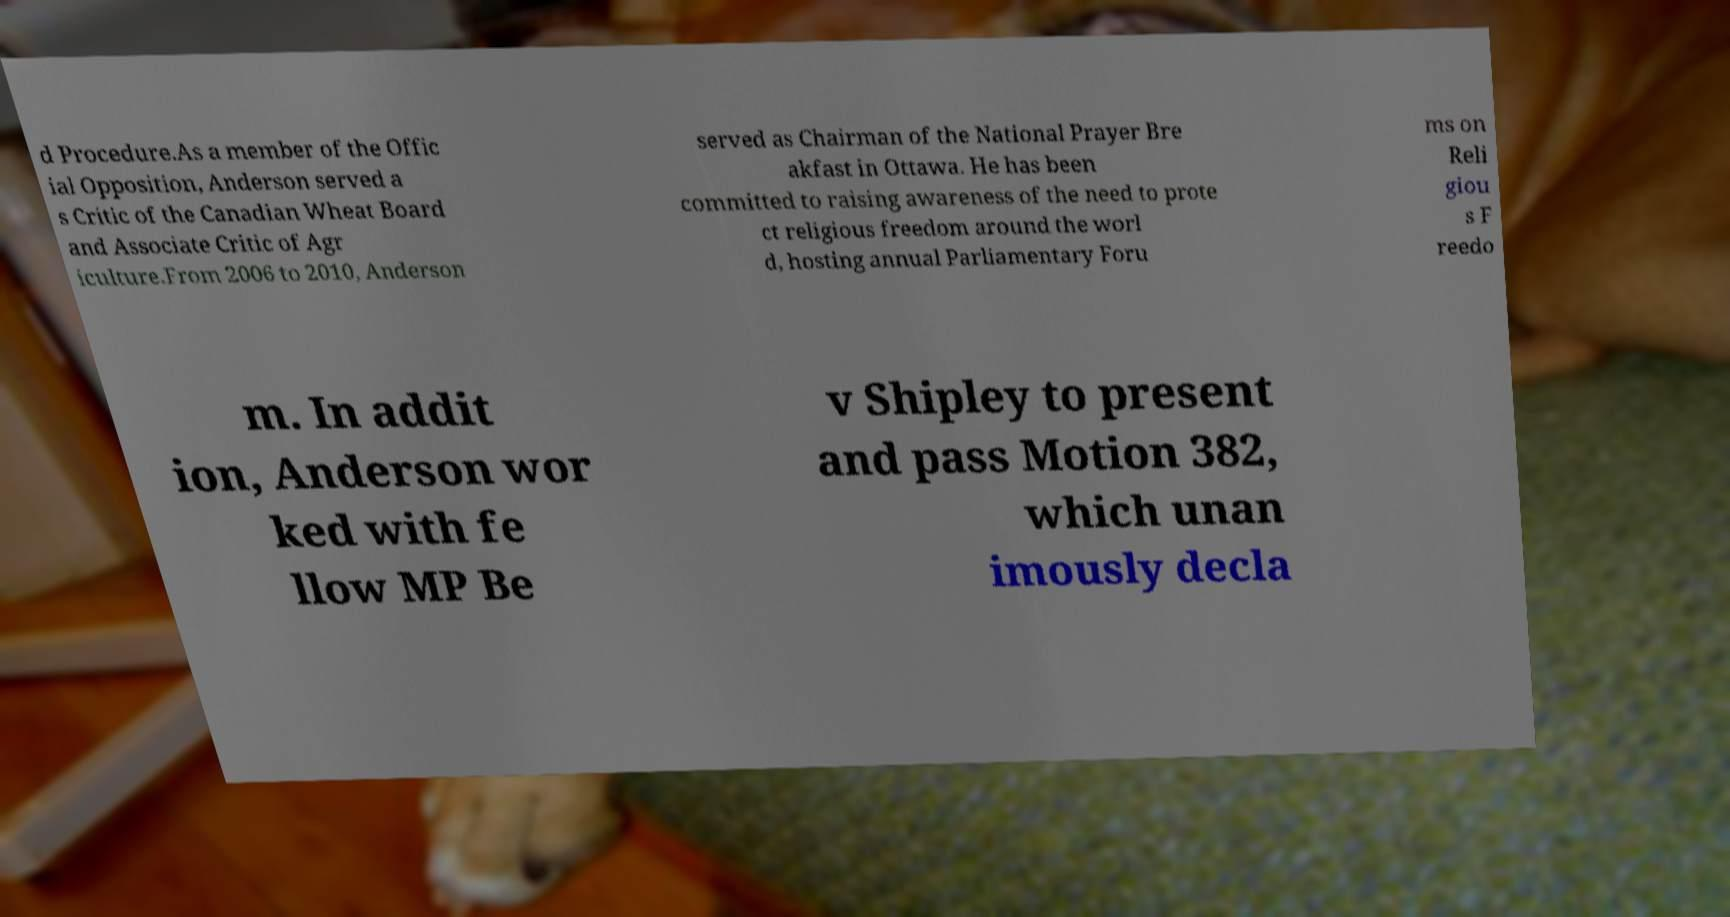For documentation purposes, I need the text within this image transcribed. Could you provide that? d Procedure.As a member of the Offic ial Opposition, Anderson served a s Critic of the Canadian Wheat Board and Associate Critic of Agr iculture.From 2006 to 2010, Anderson served as Chairman of the National Prayer Bre akfast in Ottawa. He has been committed to raising awareness of the need to prote ct religious freedom around the worl d, hosting annual Parliamentary Foru ms on Reli giou s F reedo m. In addit ion, Anderson wor ked with fe llow MP Be v Shipley to present and pass Motion 382, which unan imously decla 